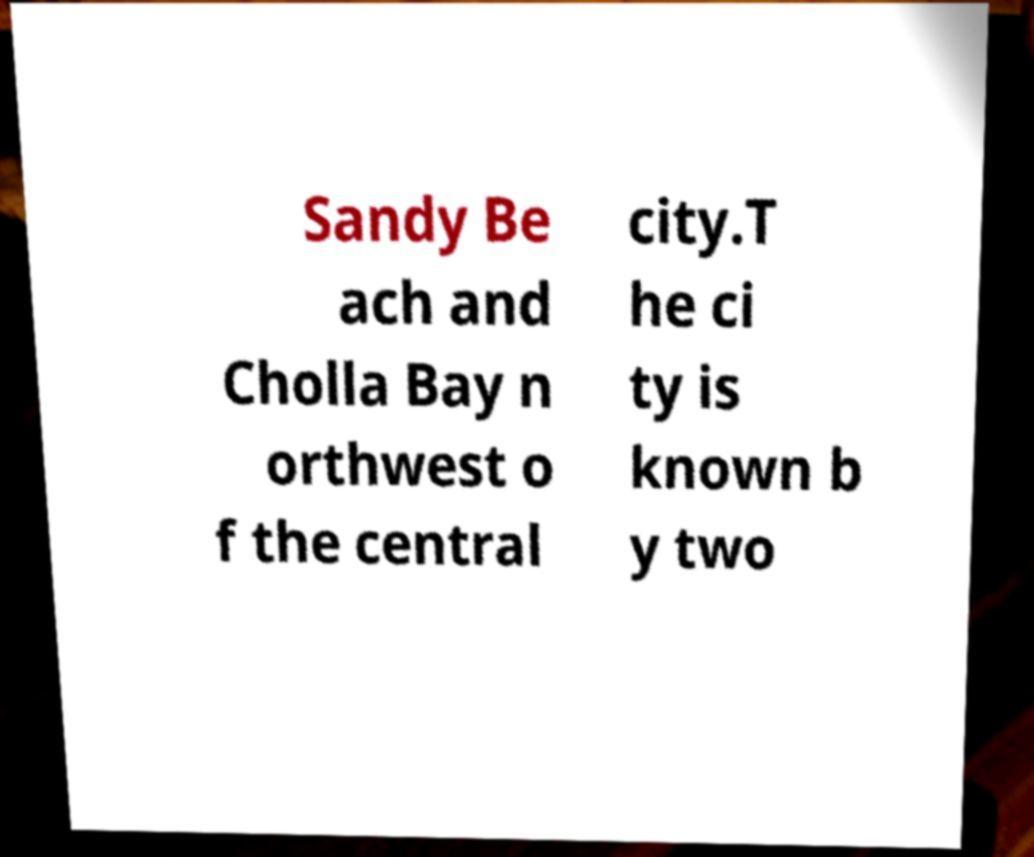For documentation purposes, I need the text within this image transcribed. Could you provide that? Sandy Be ach and Cholla Bay n orthwest o f the central city.T he ci ty is known b y two 